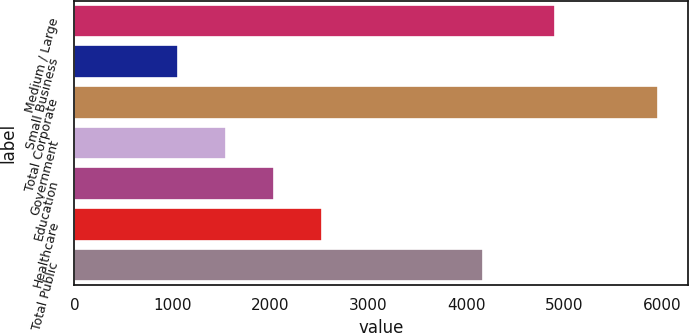<chart> <loc_0><loc_0><loc_500><loc_500><bar_chart><fcel>Medium / Large<fcel>Small Business<fcel>Total Corporate<fcel>Government<fcel>Education<fcel>Healthcare<fcel>Total Public<nl><fcel>4902.6<fcel>1057.5<fcel>5960.1<fcel>1547.76<fcel>2038.02<fcel>2528.28<fcel>4164.5<nl></chart> 